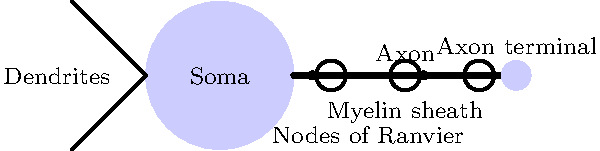In the diagram of a neuron, which structure is responsible for rapidly conducting electrical signals along the length of the axon, and how does it achieve this function? To answer this question, let's break down the components of a neuron and their functions:

1. Soma: The cell body containing the nucleus and other organelles.
2. Dendrites: Branched extensions that receive signals from other neurons.
3. Axon: The long projection that conducts electrical signals away from the soma.
4. Myelin sheath: The insulating layer surrounding the axon.
5. Nodes of Ranvier: Gaps in the myelin sheath.
6. Axon terminal: The end of the axon where neurotransmitters are released.

The structure responsible for rapidly conducting electrical signals along the length of the axon is the myelin sheath. It achieves this function through:

1. Insulation: The myelin sheath is composed of lipid-rich material that insulates the axon, preventing the loss of electrical charge.

2. Saltatory conduction: The myelin sheath is interrupted at regular intervals by the nodes of Ranvier. This allows the electrical signal to "jump" from one node to the next, significantly increasing the speed of signal propagation.

3. Increased resistance: The myelin sheath increases the electrical resistance of the axon membrane, reducing the current flow across it.

4. Decreased capacitance: The myelin sheath also decreases the capacitance of the axon membrane, allowing for faster changes in voltage.

These properties of the myelin sheath enable action potentials to propagate much faster along myelinated axons compared to unmyelinated ones, with speeds up to 100 times faster in some cases.
Answer: Myelin sheath; it insulates the axon and enables saltatory conduction. 